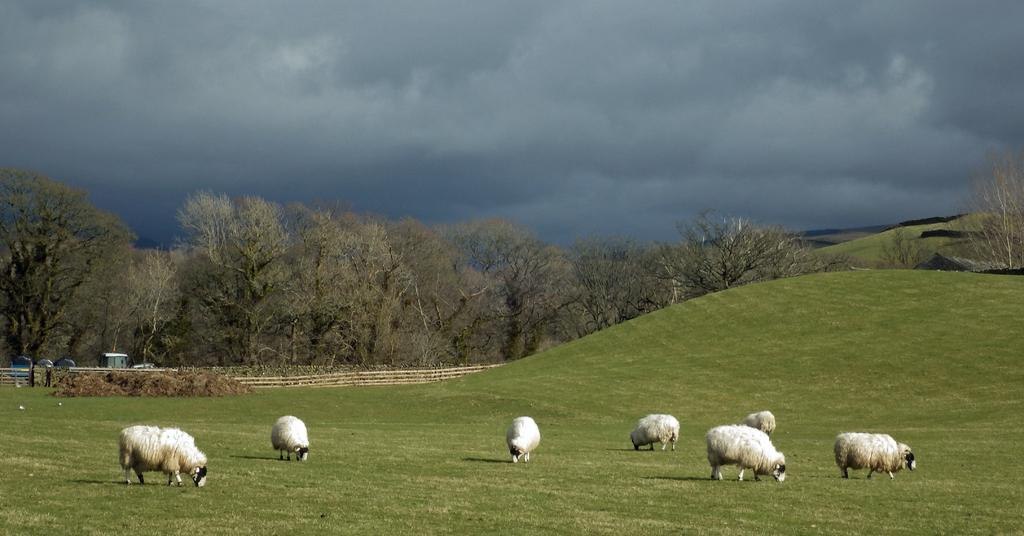What animals can be seen in the image? There are sheep grazing in the image. Where are the sheep located? The sheep are on the ground. What type of vegetation is present on the ground? There is grass on the ground. What else can be seen in the image besides the sheep? There are trees, a railing, and the sky visible in the image. What is the condition of the sky in the image? The sky is visible in the background, and there are clouds in the sky. What type of skirt is the son wearing in the image? There is no son or skirt present in the image; it features sheep grazing on grass with trees and a railing in the background. 